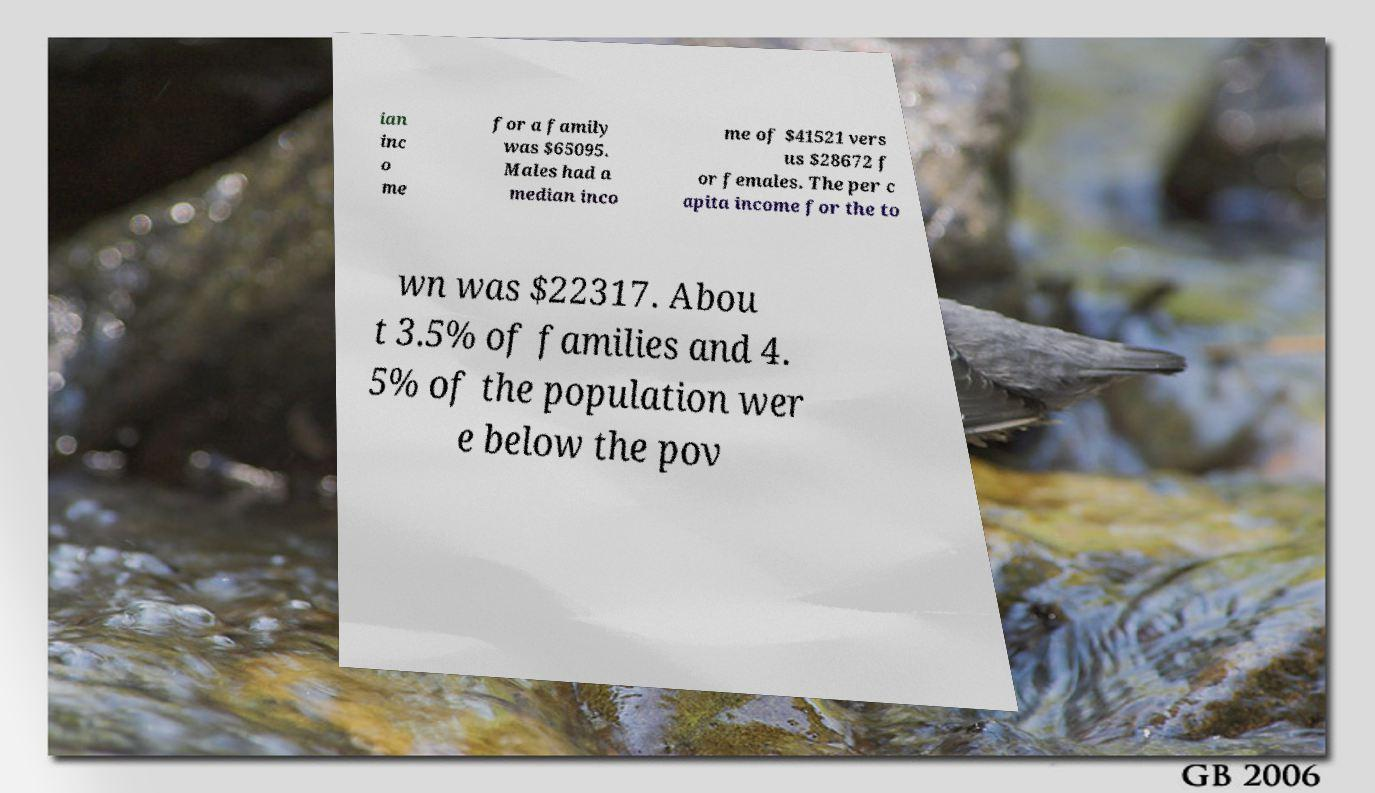There's text embedded in this image that I need extracted. Can you transcribe it verbatim? ian inc o me for a family was $65095. Males had a median inco me of $41521 vers us $28672 f or females. The per c apita income for the to wn was $22317. Abou t 3.5% of families and 4. 5% of the population wer e below the pov 